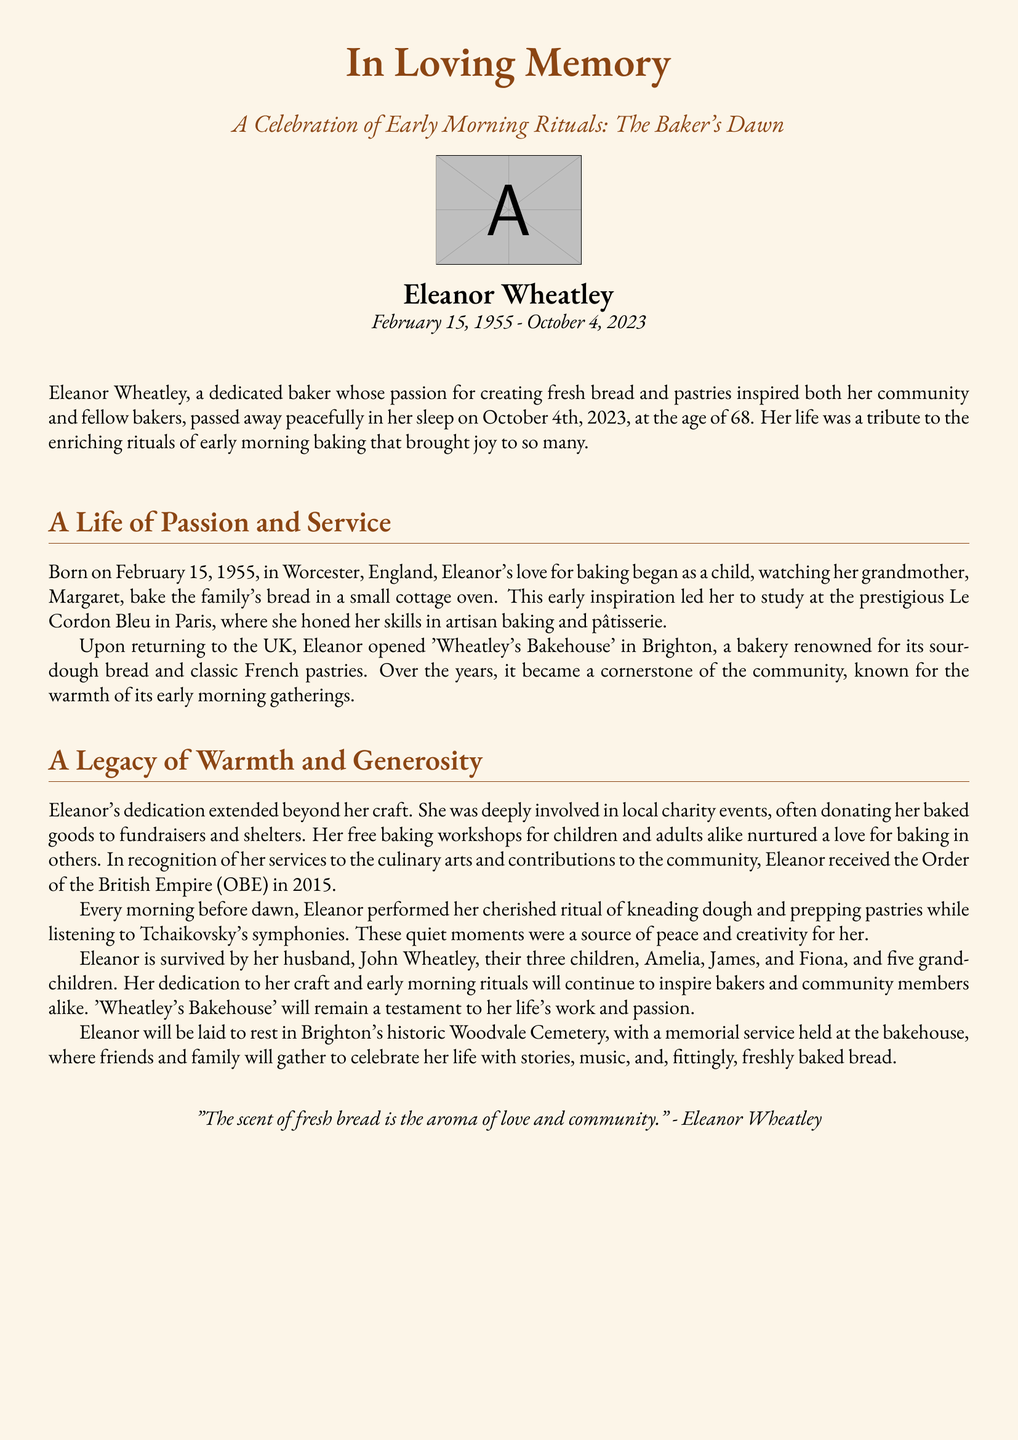What is the name of the baker? The document states the name of the baker as Eleanor Wheatley.
Answer: Eleanor Wheatley What date did Eleanor Wheatley pass away? The document mentions that Eleanor Wheatley passed away on October 4th, 2023.
Answer: October 4th, 2023 Where was Eleanor born? The document indicates that Eleanor was born in Worcester, England.
Answer: Worcester, England What organization awarded Eleanor an honor in 2015? The document states that Eleanor received the Order of the British Empire (OBE) in 2015.
Answer: Order of the British Empire (OBE) What was the name of Eleanor's bakery? The document refers to Eleanor's bakery as 'Wheatley's Bakehouse.'
Answer: Wheatley's Bakehouse How old was Eleanor when she passed away? The document notes that Eleanor was 68 years old at the time of her passing.
Answer: 68 What early morning ritual did Eleanor perform daily? The document describes her ritual of kneading dough and prepping pastries as a cherished activity.
Answer: Kneading dough and prepping pastries What musical composer did Eleanor listen to while baking? The document indicates that Eleanor listened to Tchaikovsky's symphonies during her baking.
Answer: Tchaikovsky Where will Eleanor be laid to rest? The document mentions she will be laid to rest in Brighton's historic Woodvale Cemetery.
Answer: Brighton's historic Woodvale Cemetery 